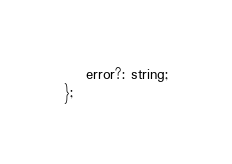Convert code to text. <code><loc_0><loc_0><loc_500><loc_500><_TypeScript_>    error?: string;
};</code> 